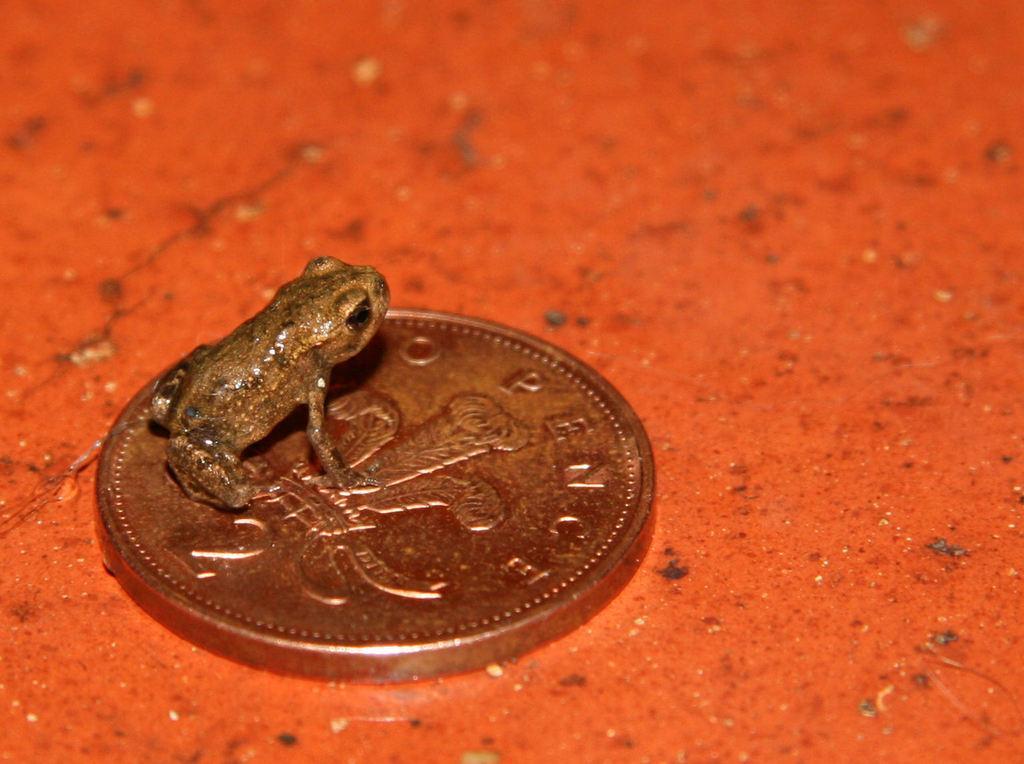In one or two sentences, can you explain what this image depicts? There is a coin on a red surface. On the coin there is a frog. 